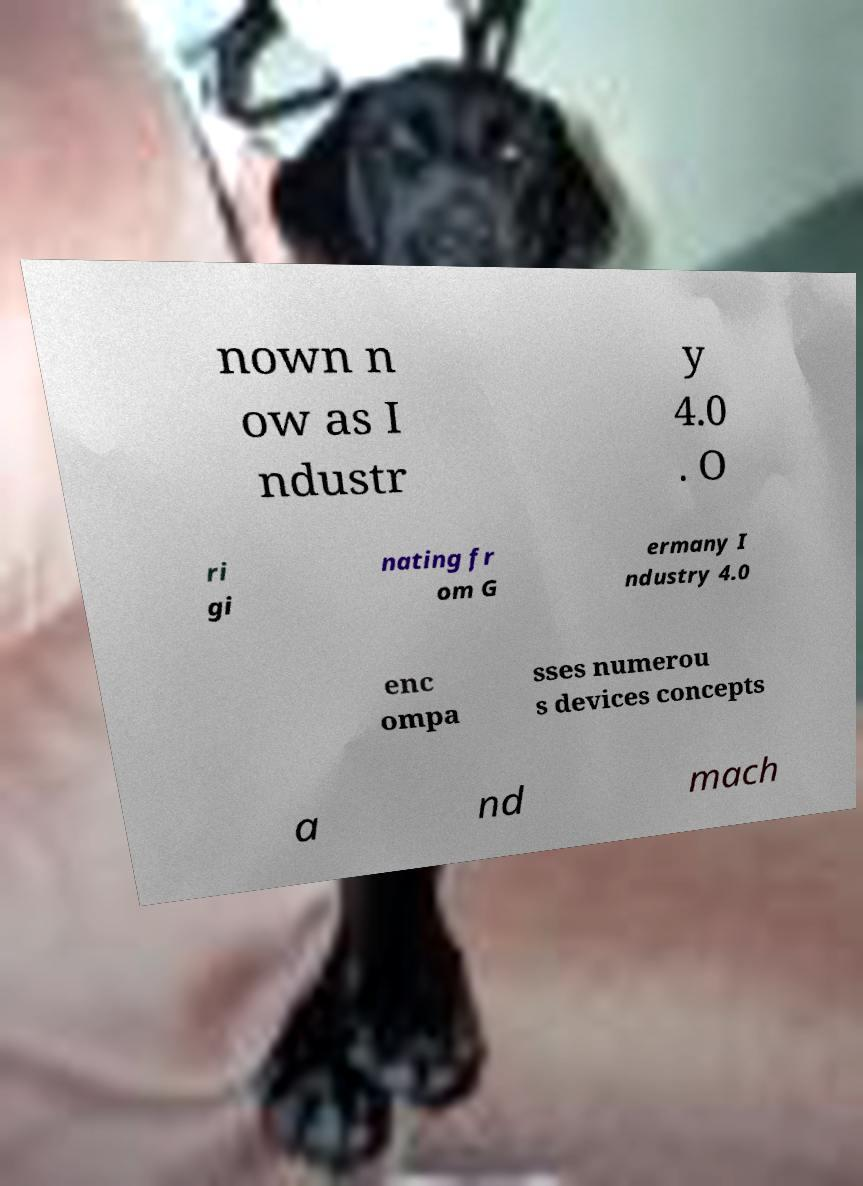There's text embedded in this image that I need extracted. Can you transcribe it verbatim? nown n ow as I ndustr y 4.0 . O ri gi nating fr om G ermany I ndustry 4.0 enc ompa sses numerou s devices concepts a nd mach 